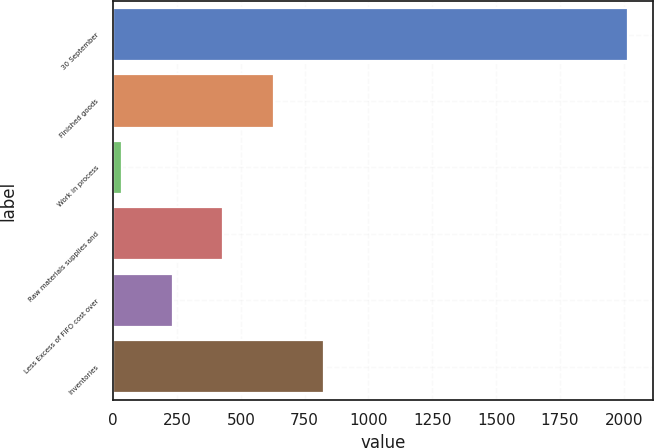<chart> <loc_0><loc_0><loc_500><loc_500><bar_chart><fcel>30 September<fcel>Finished goods<fcel>Work in process<fcel>Raw materials supplies and<fcel>Less Excess of FIFO cost over<fcel>Inventories<nl><fcel>2015<fcel>628.58<fcel>34.4<fcel>430.52<fcel>232.46<fcel>826.64<nl></chart> 